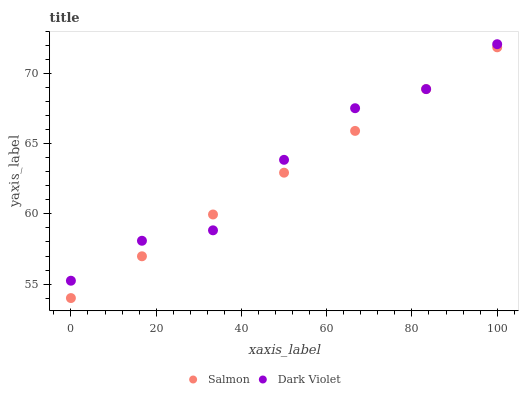Does Salmon have the minimum area under the curve?
Answer yes or no. Yes. Does Dark Violet have the maximum area under the curve?
Answer yes or no. Yes. Does Dark Violet have the minimum area under the curve?
Answer yes or no. No. Is Salmon the smoothest?
Answer yes or no. Yes. Is Dark Violet the roughest?
Answer yes or no. Yes. Is Dark Violet the smoothest?
Answer yes or no. No. Does Salmon have the lowest value?
Answer yes or no. Yes. Does Dark Violet have the lowest value?
Answer yes or no. No. Does Dark Violet have the highest value?
Answer yes or no. Yes. Does Dark Violet intersect Salmon?
Answer yes or no. Yes. Is Dark Violet less than Salmon?
Answer yes or no. No. Is Dark Violet greater than Salmon?
Answer yes or no. No. 